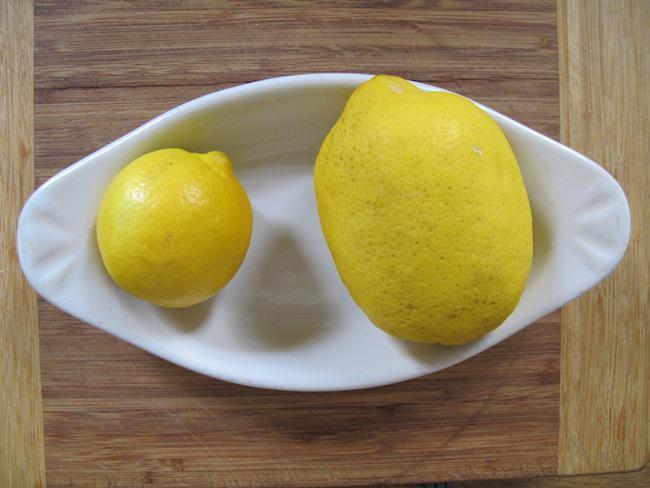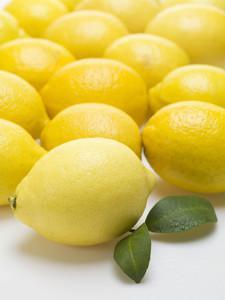The first image is the image on the left, the second image is the image on the right. Given the left and right images, does the statement "There are only two whole lemons in one of the images." hold true? Answer yes or no. Yes. The first image is the image on the left, the second image is the image on the right. For the images displayed, is the sentence "The left image shows sliced fruit and the right image shows whole fruit." factually correct? Answer yes or no. No. 